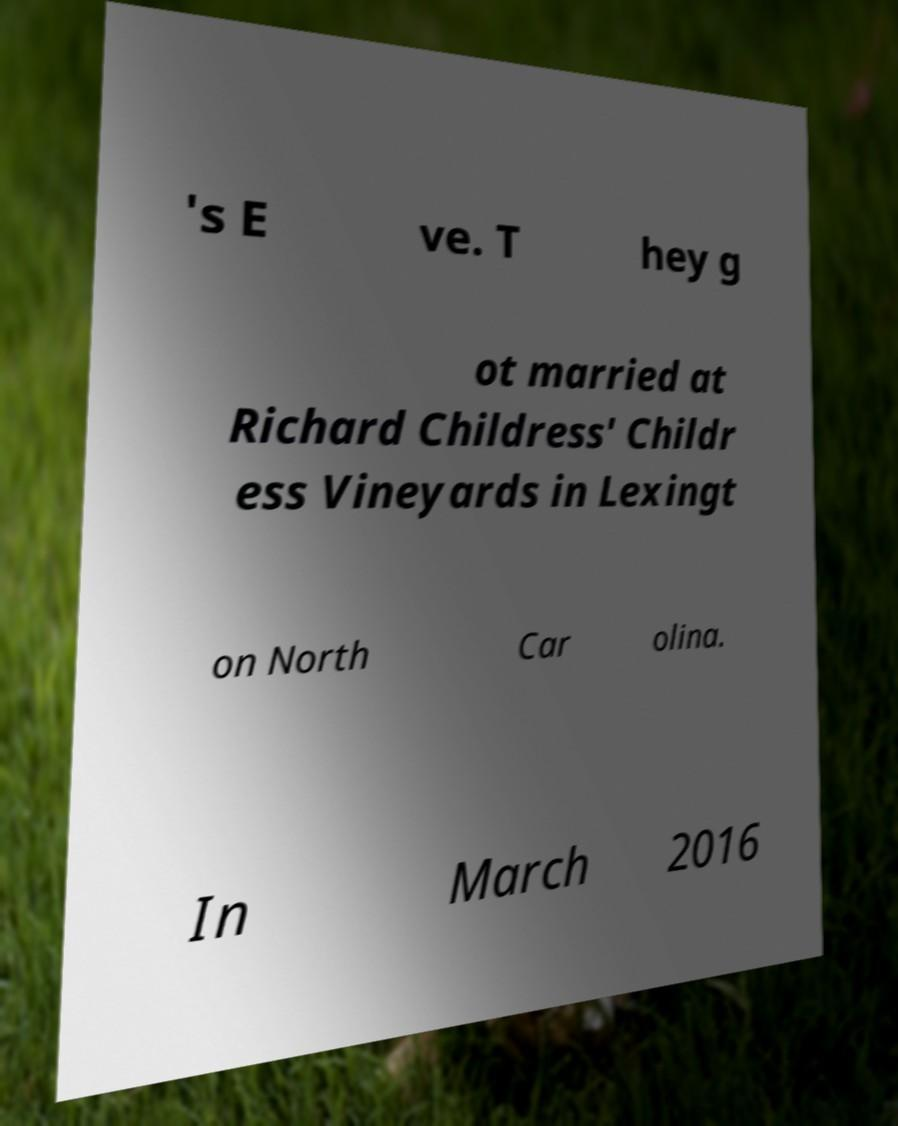There's text embedded in this image that I need extracted. Can you transcribe it verbatim? 's E ve. T hey g ot married at Richard Childress' Childr ess Vineyards in Lexingt on North Car olina. In March 2016 